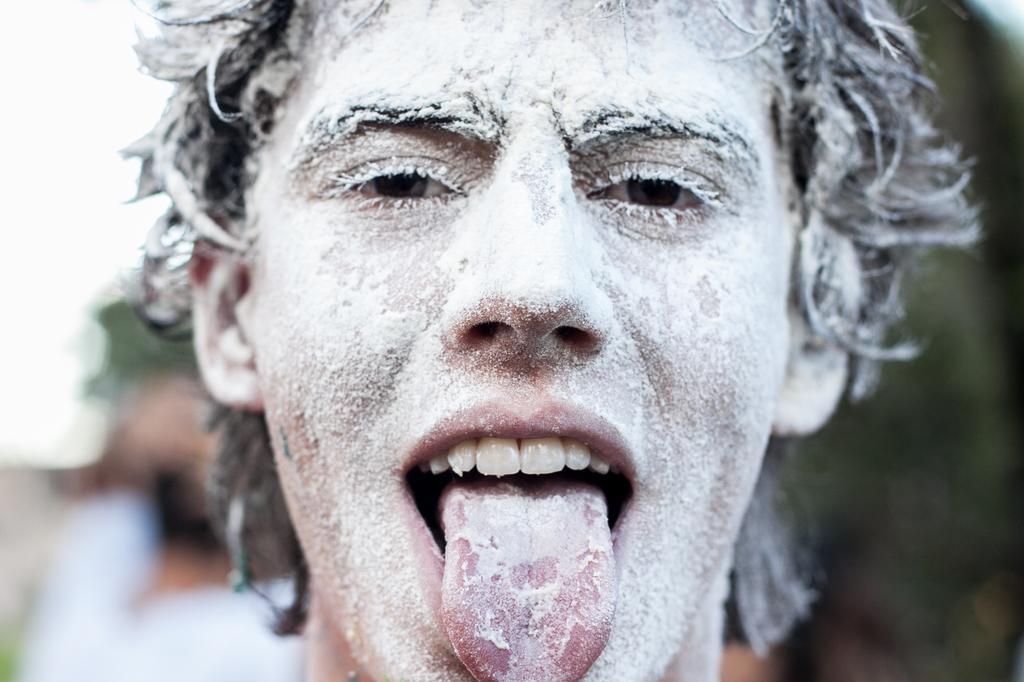Describe this image in one or two sentences. In this image I can see the person's face covered with the white color powder and I can see the blurred background. 